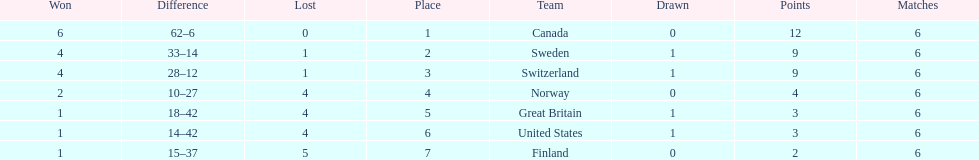Which country conceded the least goals? Finland. 